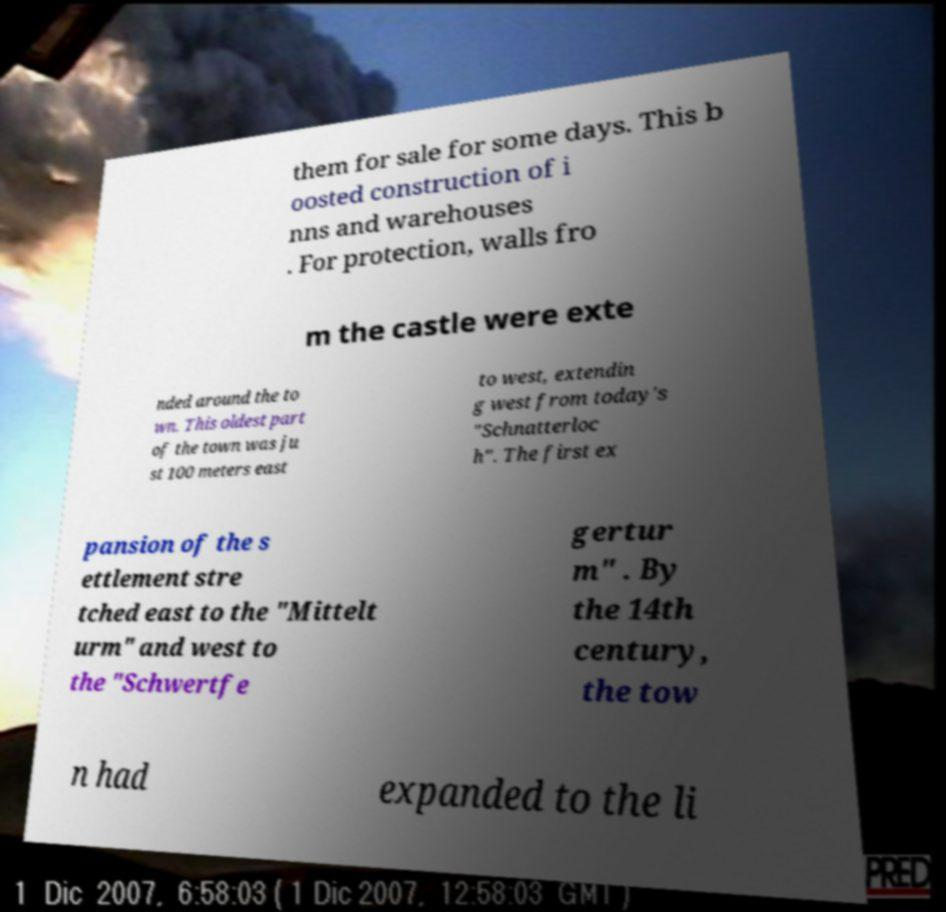For documentation purposes, I need the text within this image transcribed. Could you provide that? them for sale for some days. This b oosted construction of i nns and warehouses . For protection, walls fro m the castle were exte nded around the to wn. This oldest part of the town was ju st 100 meters east to west, extendin g west from today's "Schnatterloc h". The first ex pansion of the s ettlement stre tched east to the "Mittelt urm" and west to the "Schwertfe gertur m" . By the 14th century, the tow n had expanded to the li 